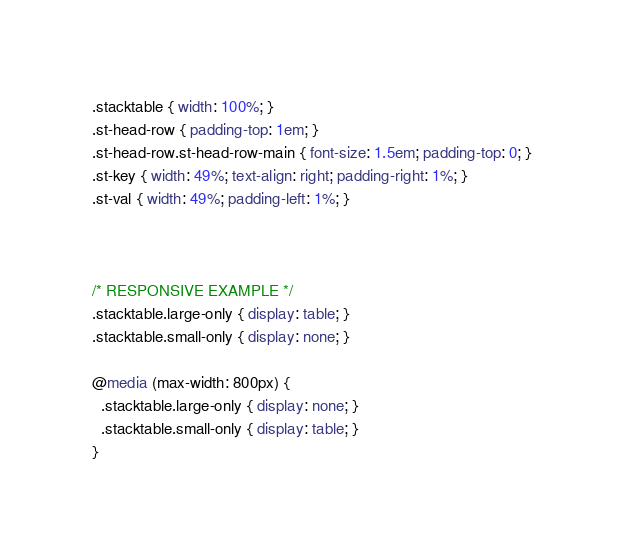<code> <loc_0><loc_0><loc_500><loc_500><_CSS_>.stacktable { width: 100%; }
.st-head-row { padding-top: 1em; }
.st-head-row.st-head-row-main { font-size: 1.5em; padding-top: 0; }
.st-key { width: 49%; text-align: right; padding-right: 1%; }
.st-val { width: 49%; padding-left: 1%; }



/* RESPONSIVE EXAMPLE */
.stacktable.large-only { display: table; }
.stacktable.small-only { display: none; }

@media (max-width: 800px) {
  .stacktable.large-only { display: none; }
  .stacktable.small-only { display: table; }
}</code> 